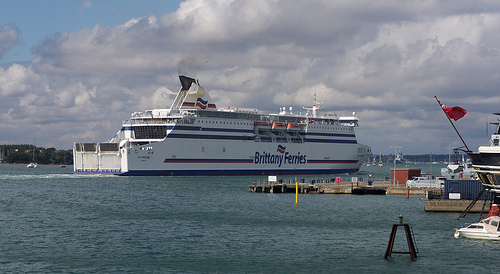Describe the atmosphere and scenery in the image. The atmosphere in the image is tranquil, with calm blue waters and a mostly cloudy sky. The clouds are predominantly white, creating a peaceful and serene backdrop. Can you provide more details about the surroundings and the dock area? Certainly! The dock area in the image features a mix of structures and objects, including a red flag on a flagpole, a blue crate, and an old rusted buoy. The pier appears to be functional, with mooring equipment and safety posts. Some smaller boats are also docked nearby, and the general vibe is that of a busy yet orderly port. Imagine you could dive into the water seen in the image. What kind of marine life might you encounter there? Diving into the calm blue water, one might encounter a variety of marine life, including schools of small fish darting around, seaweed swaying with the currents, and perhaps some starfish clinging to underwater rocks. There could also be crabs scuttling along the seabed and colorful anemones anchored to the pier structures. 